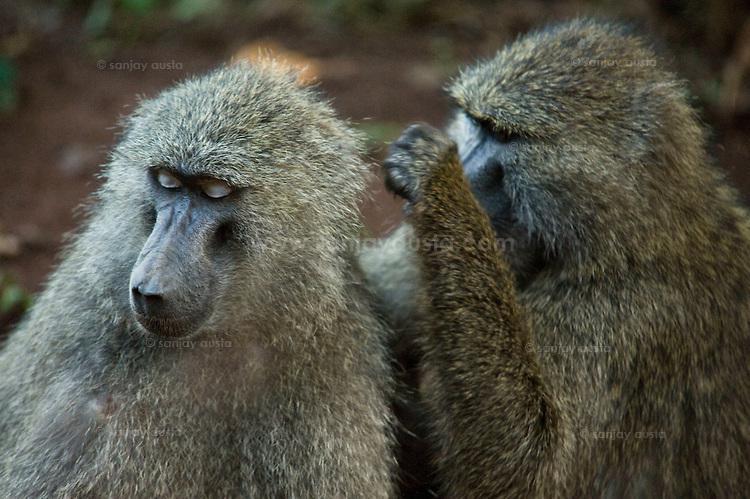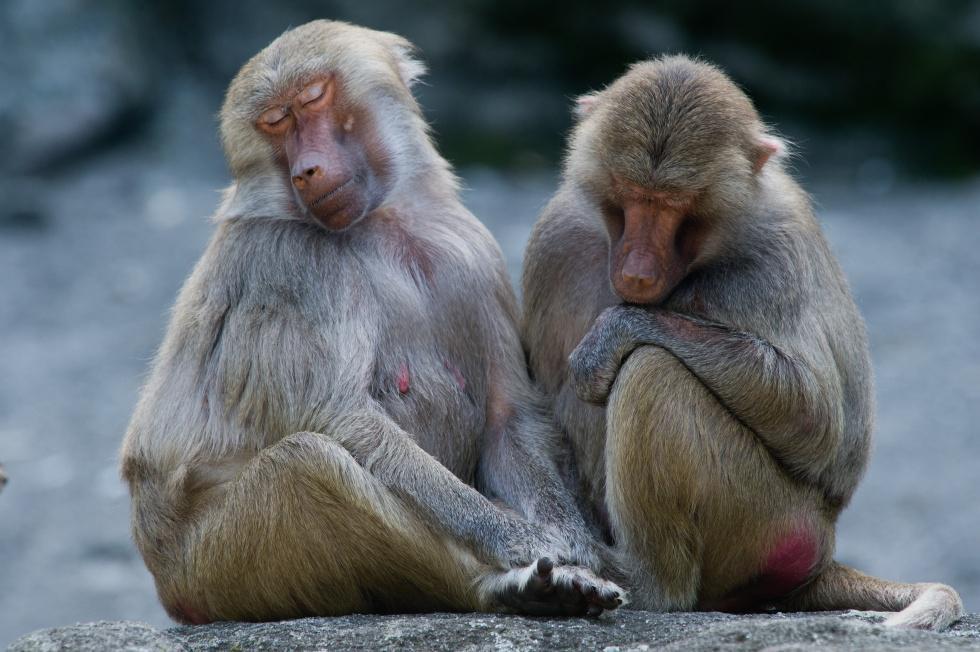The first image is the image on the left, the second image is the image on the right. Assess this claim about the two images: "The monkey on the right is grooming the face of the monkey on the left.". Correct or not? Answer yes or no. No. 